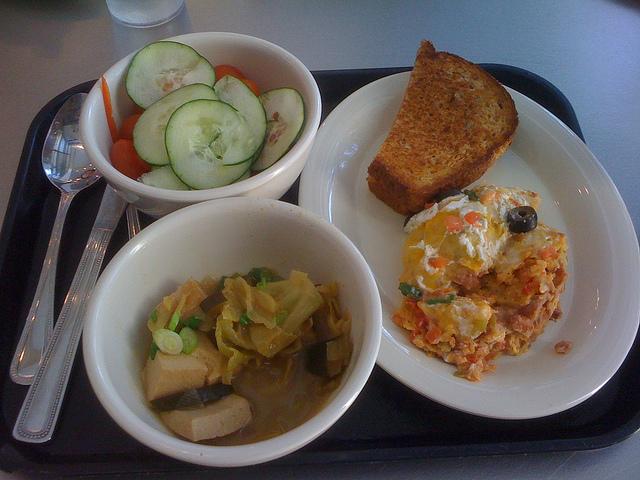How many spoons do you see?
Quick response, please. 1. What meal is this fruit most associated with?
Be succinct. Lunch. Where would it be more normal to set these objects?
Write a very short answer. Table. What is the name of the dish on the right?
Be succinct. Omelet. Are those chopsticks?
Keep it brief. No. How many bowls are there?
Give a very brief answer. 2. What is the green vegetable?
Quick response, please. Cucumber. Is this food?
Be succinct. Yes. What kind of utensils are there?
Give a very brief answer. Spoon and knife. Is that a whole sandwich?
Keep it brief. No. What are the silverware sitting on?
Concise answer only. Tray. Where is the bread?
Answer briefly. Plate. Is there a jar?
Keep it brief. No. How many type of food is there?
Concise answer only. 4. What kind of vegetables are on the table?
Short answer required. Cucumber. What kind of food are they eating?
Keep it brief. American. Do they have salad?
Short answer required. Yes. How many foods are uneaten?
Quick response, please. 4. 